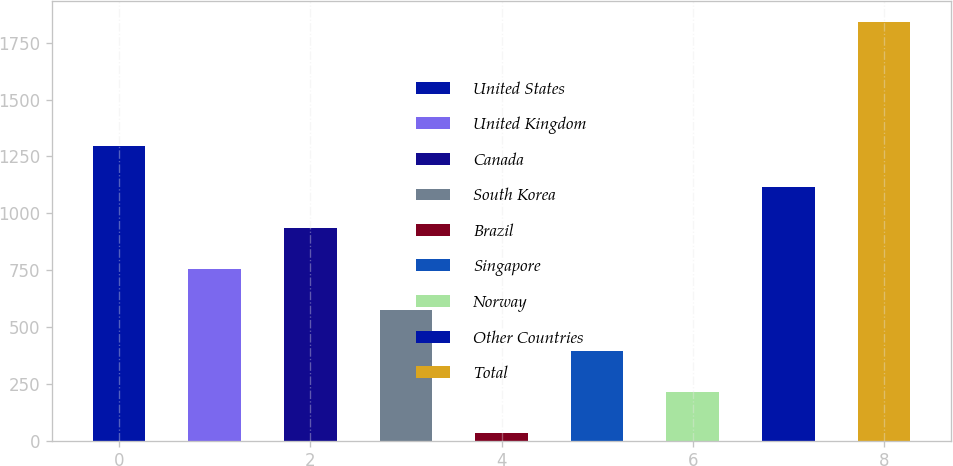<chart> <loc_0><loc_0><loc_500><loc_500><bar_chart><fcel>United States<fcel>United Kingdom<fcel>Canada<fcel>South Korea<fcel>Brazil<fcel>Singapore<fcel>Norway<fcel>Other Countries<fcel>Total<nl><fcel>1297.6<fcel>755.2<fcel>936<fcel>574.4<fcel>32<fcel>393.6<fcel>212.8<fcel>1116.8<fcel>1840<nl></chart> 